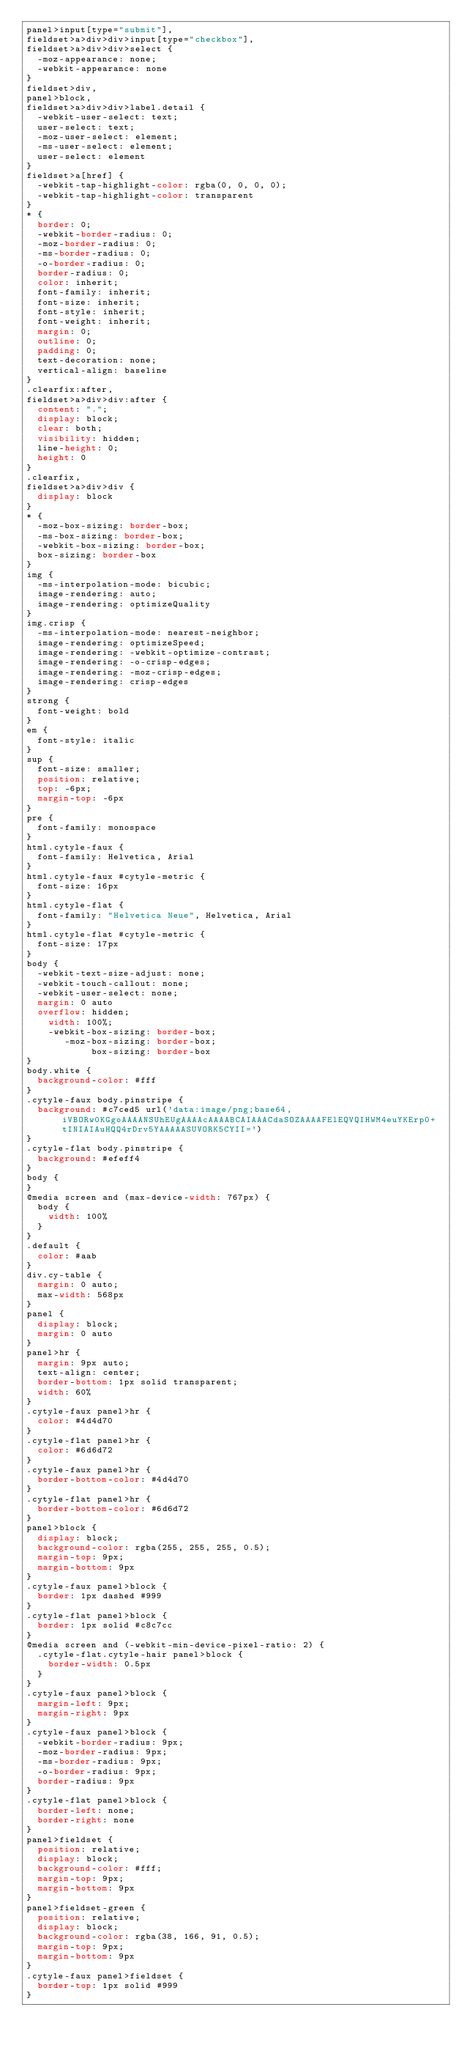Convert code to text. <code><loc_0><loc_0><loc_500><loc_500><_CSS_>panel>input[type="submit"],
fieldset>a>div>div>input[type="checkbox"],
fieldset>a>div>div>select {
  -moz-appearance: none;
  -webkit-appearance: none
}
fieldset>div,
panel>block,
fieldset>a>div>div>label.detail {
  -webkit-user-select: text;
  user-select: text;
  -moz-user-select: element;
  -ms-user-select: element;
  user-select: element
}
fieldset>a[href] {
  -webkit-tap-highlight-color: rgba(0, 0, 0, 0);
  -webkit-tap-highlight-color: transparent
}
* {
  border: 0;
  -webkit-border-radius: 0;
  -moz-border-radius: 0;
  -ms-border-radius: 0;
  -o-border-radius: 0;
  border-radius: 0;
  color: inherit;
  font-family: inherit;
  font-size: inherit;
  font-style: inherit;
  font-weight: inherit;
  margin: 0;
  outline: 0;
  padding: 0;
  text-decoration: none;
  vertical-align: baseline
}
.clearfix:after,
fieldset>a>div>div:after {
  content: ".";
  display: block;
  clear: both;
  visibility: hidden;
  line-height: 0;
  height: 0
}
.clearfix,
fieldset>a>div>div {
  display: block
}
* {
  -moz-box-sizing: border-box;
  -ms-box-sizing: border-box;
  -webkit-box-sizing: border-box;
  box-sizing: border-box
}
img {
  -ms-interpolation-mode: bicubic;
  image-rendering: auto;
  image-rendering: optimizeQuality
}
img.crisp {
  -ms-interpolation-mode: nearest-neighbor;
  image-rendering: optimizeSpeed;
  image-rendering: -webkit-optimize-contrast;
  image-rendering: -o-crisp-edges;
  image-rendering: -moz-crisp-edges;
  image-rendering: crisp-edges
}
strong {
  font-weight: bold
}
em {
  font-style: italic
}
sup {
  font-size: smaller;
  position: relative;
  top: -6px;
  margin-top: -6px
}
pre {
  font-family: monospace
}
html.cytyle-faux {
  font-family: Helvetica, Arial
}
html.cytyle-faux #cytyle-metric {
  font-size: 16px
}
html.cytyle-flat {
  font-family: "Helvetica Neue", Helvetica, Arial
}
html.cytyle-flat #cytyle-metric {
  font-size: 17px
}
body {
  -webkit-text-size-adjust: none;
  -webkit-touch-callout: none;
  -webkit-user-select: none;
  margin: 0 auto
  overflow: hidden;
    width: 100%;
    -webkit-box-sizing: border-box;
       -moz-box-sizing: border-box;
            box-sizing: border-box
}
body.white {
  background-color: #fff
}
.cytyle-faux body.pinstripe {
  background: #c7ced5 url('data:image/png;base64,iVBORw0KGgoAAAANSUhEUgAAAAcAAAABCAIAAACdaSOZAAAAFElEQVQIHWM4euYKErp0+tINIAIAuHQQ4rDrv5YAAAAASUVORK5CYII=')
}
.cytyle-flat body.pinstripe {
  background: #efeff4
}
body {
}
@media screen and (max-device-width: 767px) {
  body {
    width: 100%
  }
}
.default {
  color: #aab
}
div.cy-table {
  margin: 0 auto;
  max-width: 568px
}
panel {
  display: block;
  margin: 0 auto
}
panel>hr {
  margin: 9px auto;
  text-align: center;
  border-bottom: 1px solid transparent;
  width: 60%
}
.cytyle-faux panel>hr {
  color: #4d4d70
}
.cytyle-flat panel>hr {
  color: #6d6d72
}
.cytyle-faux panel>hr {
  border-bottom-color: #4d4d70
}
.cytyle-flat panel>hr {
  border-bottom-color: #6d6d72
}
panel>block {
  display: block;
  background-color: rgba(255, 255, 255, 0.5);
  margin-top: 9px;
  margin-bottom: 9px
}
.cytyle-faux panel>block {
  border: 1px dashed #999
}
.cytyle-flat panel>block {
  border: 1px solid #c8c7cc
}
@media screen and (-webkit-min-device-pixel-ratio: 2) {
  .cytyle-flat.cytyle-hair panel>block {
    border-width: 0.5px
  }
}
.cytyle-faux panel>block {
  margin-left: 9px;
  margin-right: 9px
}
.cytyle-faux panel>block {
  -webkit-border-radius: 9px;
  -moz-border-radius: 9px;
  -ms-border-radius: 9px;
  -o-border-radius: 9px;
  border-radius: 9px
}
.cytyle-flat panel>block {
  border-left: none;
  border-right: none
}
panel>fieldset {
  position: relative;
  display: block;
  background-color: #fff;
  margin-top: 9px;
  margin-bottom: 9px
}
panel>fieldset-green {
  position: relative;
  display: block;
  background-color: rgba(38, 166, 91, 0.5);
  margin-top: 9px;
  margin-bottom: 9px
}
.cytyle-faux panel>fieldset {
  border-top: 1px solid #999
}</code> 